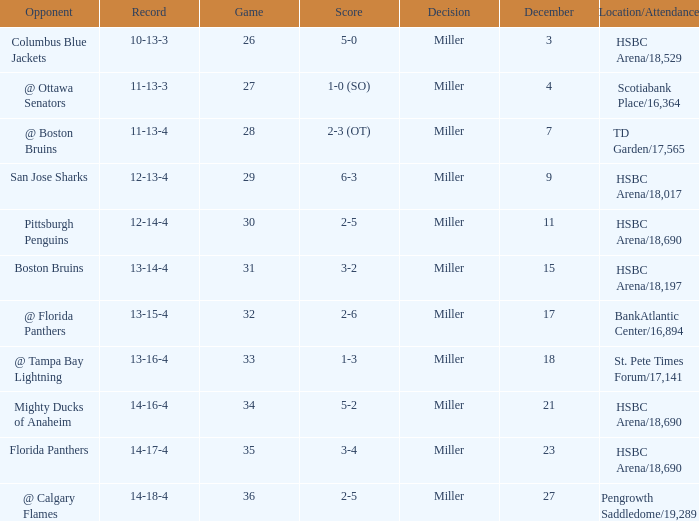Name the number of game 2-6 1.0. 